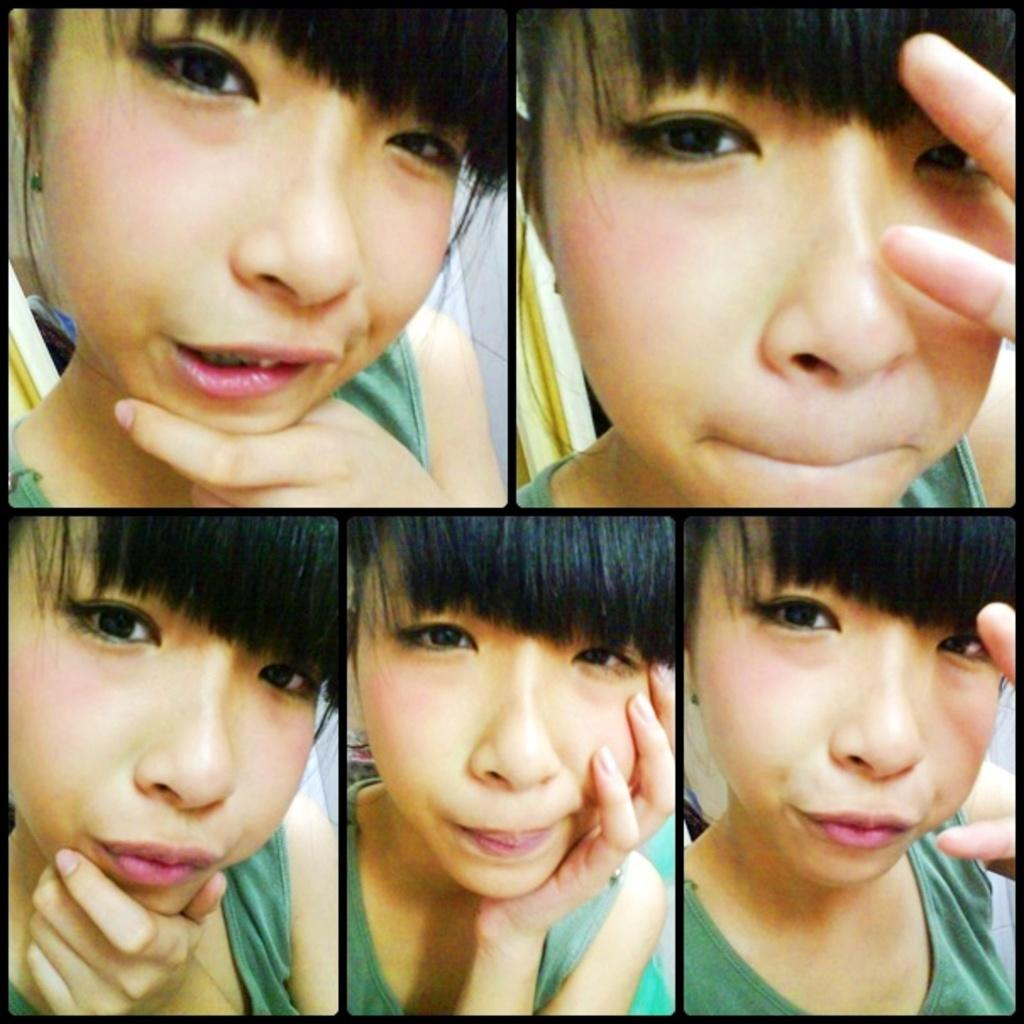What type of images are present in the picture? There are collage images in the picture. What subject matter is depicted in the collage images? The collage images depict a girl. How does the girl appear in the collage images? The girl has different faces in the collage images. What type of polish is being applied to the girl's face in the image? There is no indication in the image that any polish is being applied to the girl's face. What type of sticks are used to create the collage images? The image does not show any sticks being used to create the collage images. 